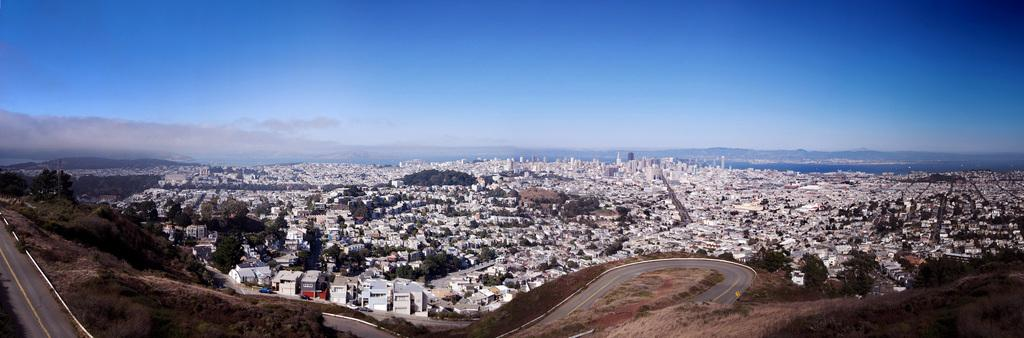What type of view is shown in the image? The image is a top view of a city. What can be seen on the ground in the image? There are roads and buildings in the image. What natural elements are present in the image? There are trees, mountains, and a sea in the image. What is visible at the top of the image? The sky is visible at the top of the image, and there are clouds in the sky. What type of ring can be seen on the finger of the person walking on the road in the image? There is no person walking on the road in the image, and therefore no ring can be seen on their finger. 